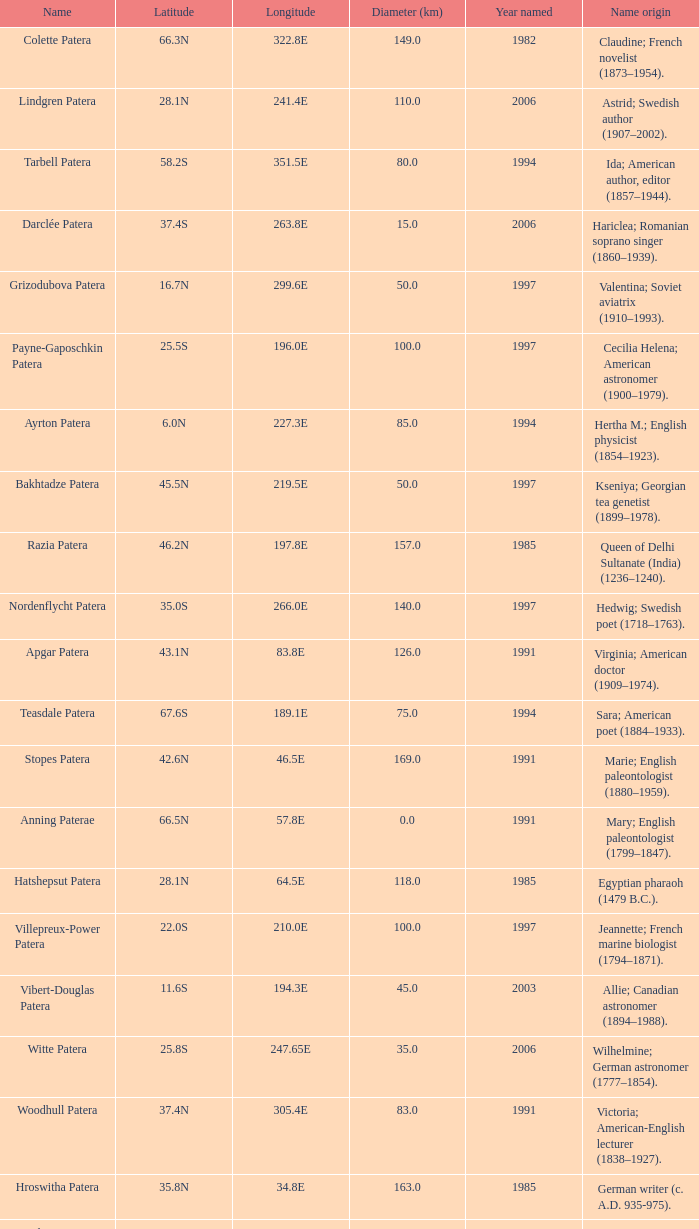What is  the diameter in km of the feature with a longitude of 40.2E?  135.0. 